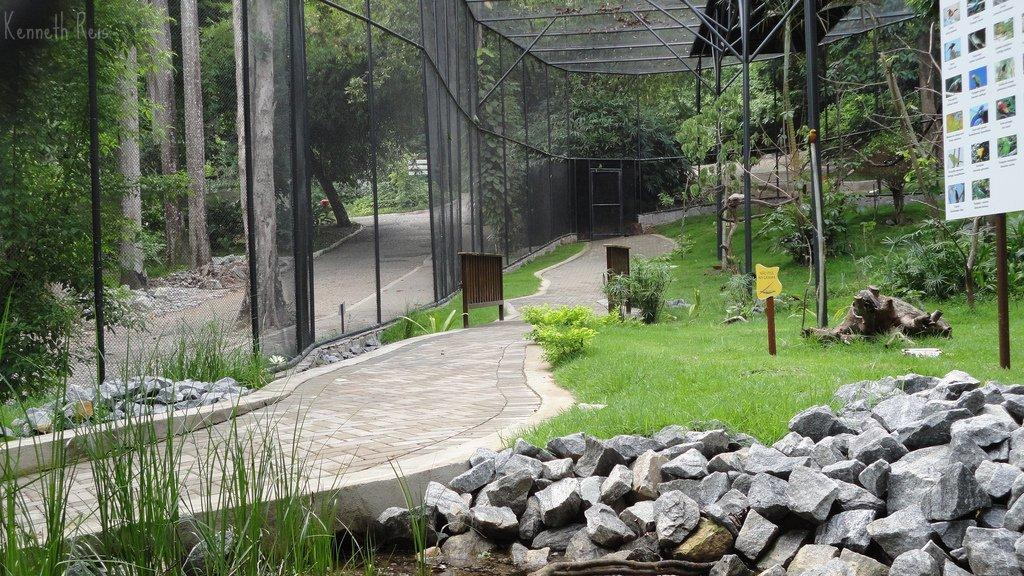What type of natural elements can be seen in the image? There are stones, grass, and trees in the background of the image. What man-made structures are present in the image? There are boards, poles, paths, and a fence in the image. Can you describe the layout of the image? The image features stones, boards, grass, poles, paths, and a fence, with trees in the background. What type of learning material can be seen on the sidewalk in the image? There is no sidewalk or learning material present in the image. What is the yoke used for in the image? There is no yoke present in the image. 